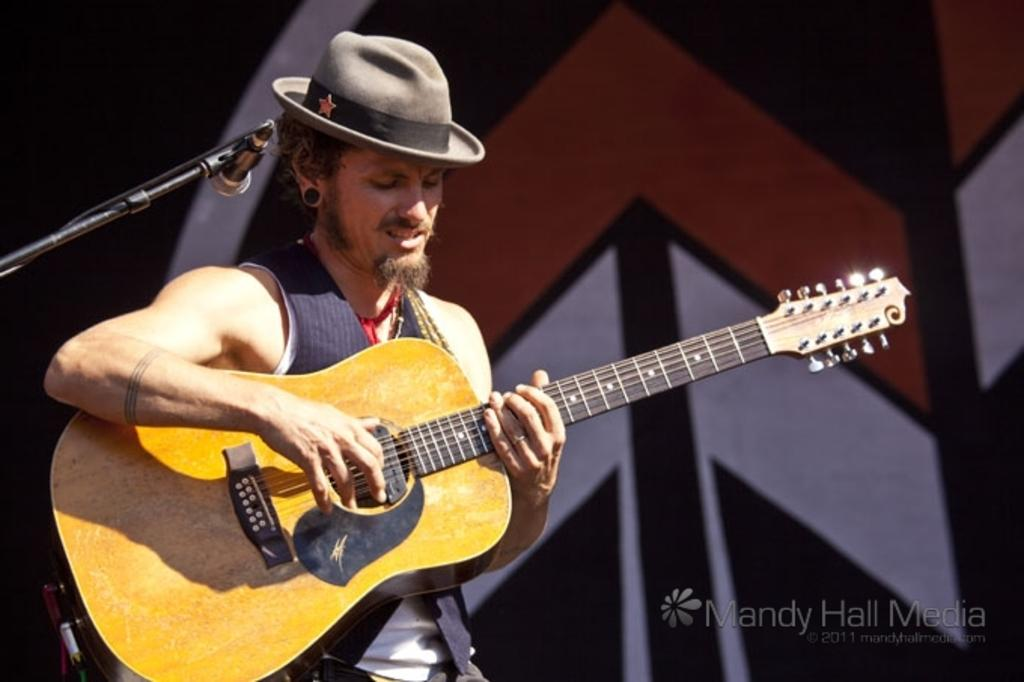What is the main subject of the image? There is a person in the image. What is the person wearing on their head? The person is wearing a hat. What is the person doing in the image? The person is standing and playing a guitar. What object is present in the image that is commonly used for amplifying sound? There is a microphone in the image. What type of punishment is being administered to the person in the image? There is no indication of punishment in the image; the person is playing a guitar and wearing a hat. What color is the vest that the person is wearing in the image? There is no vest visible in the image; the person is wearing a hat and playing a guitar. 